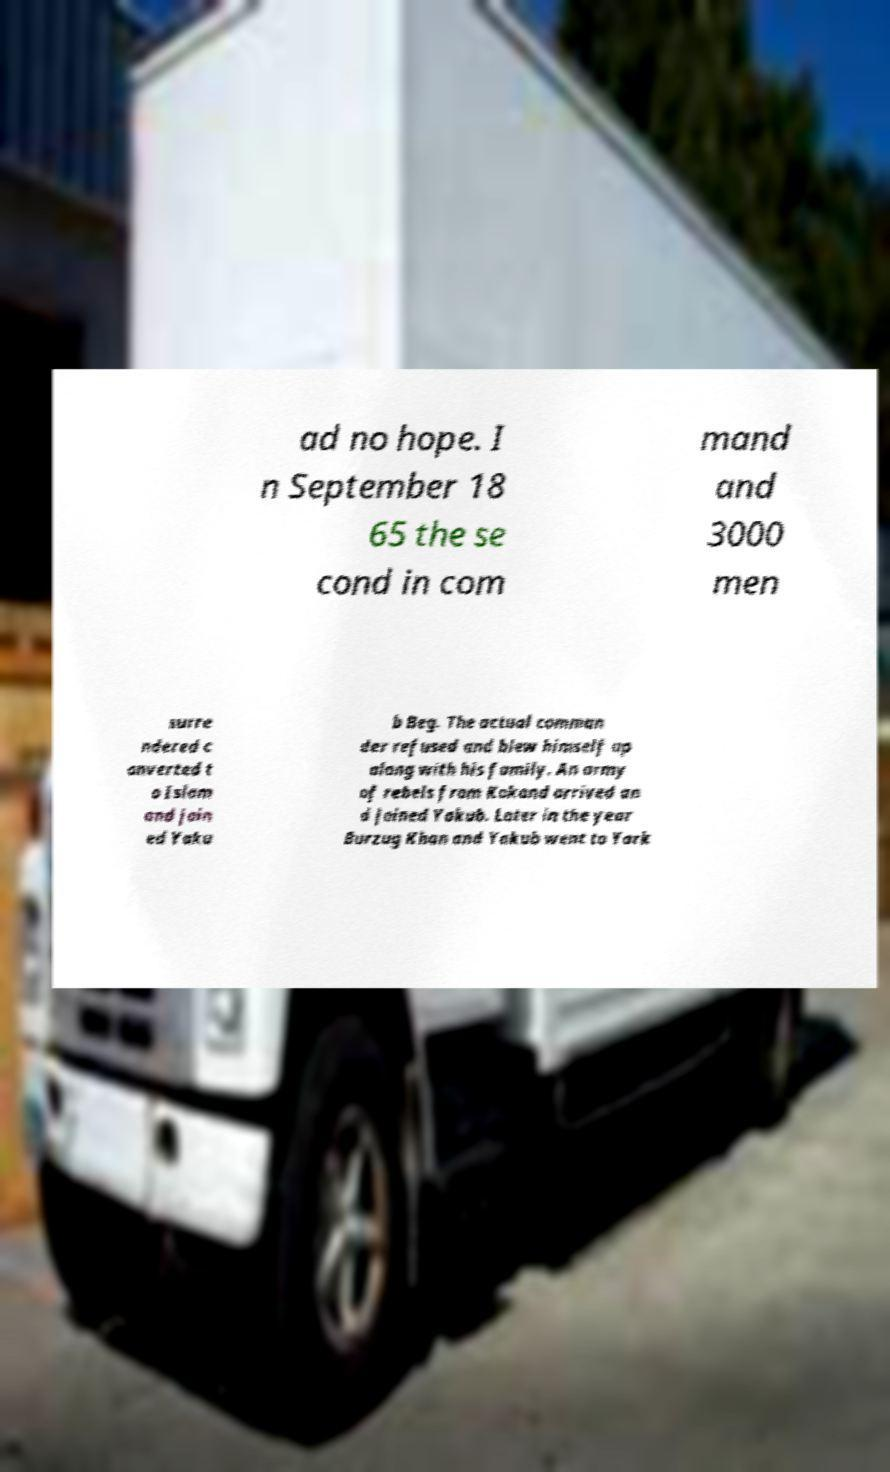Please identify and transcribe the text found in this image. ad no hope. I n September 18 65 the se cond in com mand and 3000 men surre ndered c onverted t o Islam and join ed Yaku b Beg. The actual comman der refused and blew himself up along with his family. An army of rebels from Kokand arrived an d joined Yakub. Later in the year Burzug Khan and Yakub went to Yark 